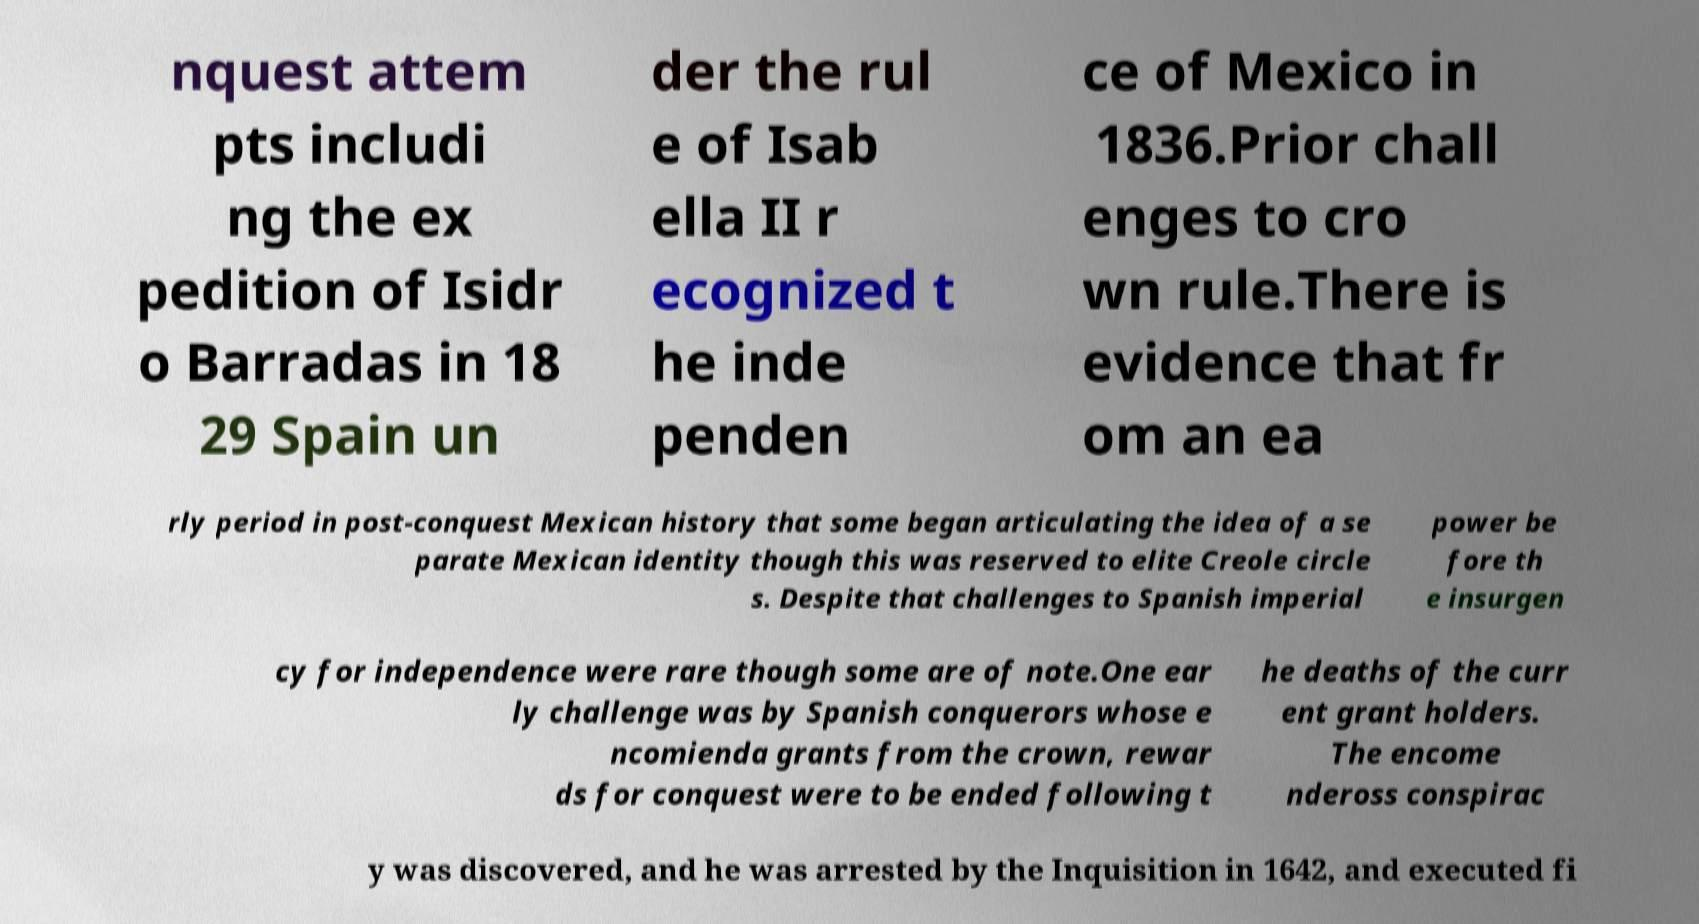Can you read and provide the text displayed in the image?This photo seems to have some interesting text. Can you extract and type it out for me? nquest attem pts includi ng the ex pedition of Isidr o Barradas in 18 29 Spain un der the rul e of Isab ella II r ecognized t he inde penden ce of Mexico in 1836.Prior chall enges to cro wn rule.There is evidence that fr om an ea rly period in post-conquest Mexican history that some began articulating the idea of a se parate Mexican identity though this was reserved to elite Creole circle s. Despite that challenges to Spanish imperial power be fore th e insurgen cy for independence were rare though some are of note.One ear ly challenge was by Spanish conquerors whose e ncomienda grants from the crown, rewar ds for conquest were to be ended following t he deaths of the curr ent grant holders. The encome ndeross conspirac y was discovered, and he was arrested by the Inquisition in 1642, and executed fi 